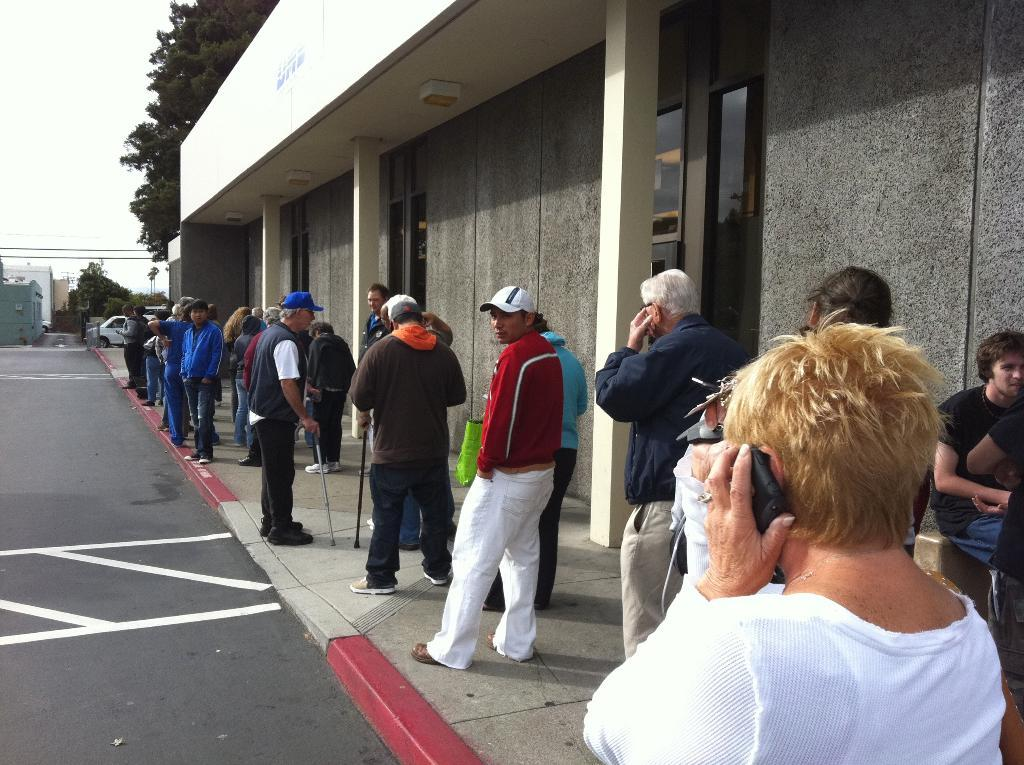How many people can be seen in the image? There are people in the image, but the exact number is not specified. What type of structure is visible in the image? There is a building in the image. What architectural feature can be seen in the image? There are pillars in the image. What is the primary mode of transportation visible in the image? There is a road in the image. What can be seen in the background of the image? In the background of the image, there is a vehicle, wires, trees, buildings, and the sky. What type of ornament is being used in the battle depicted in the image? There is no battle depicted in the image, and therefore no ornament can be associated with it. 